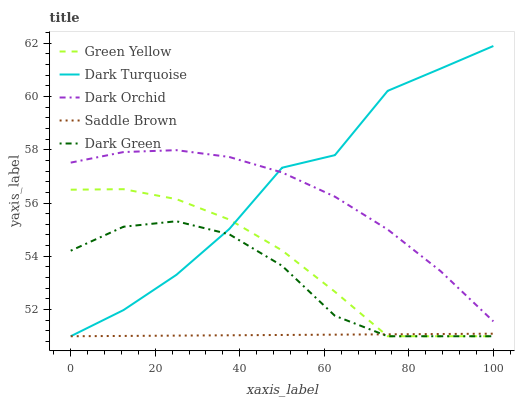Does Saddle Brown have the minimum area under the curve?
Answer yes or no. Yes. Does Dark Turquoise have the maximum area under the curve?
Answer yes or no. Yes. Does Green Yellow have the minimum area under the curve?
Answer yes or no. No. Does Green Yellow have the maximum area under the curve?
Answer yes or no. No. Is Saddle Brown the smoothest?
Answer yes or no. Yes. Is Dark Turquoise the roughest?
Answer yes or no. Yes. Is Green Yellow the smoothest?
Answer yes or no. No. Is Green Yellow the roughest?
Answer yes or no. No. Does Dark Turquoise have the lowest value?
Answer yes or no. Yes. Does Dark Orchid have the lowest value?
Answer yes or no. No. Does Dark Turquoise have the highest value?
Answer yes or no. Yes. Does Green Yellow have the highest value?
Answer yes or no. No. Is Saddle Brown less than Dark Orchid?
Answer yes or no. Yes. Is Dark Orchid greater than Green Yellow?
Answer yes or no. Yes. Does Dark Turquoise intersect Saddle Brown?
Answer yes or no. Yes. Is Dark Turquoise less than Saddle Brown?
Answer yes or no. No. Is Dark Turquoise greater than Saddle Brown?
Answer yes or no. No. Does Saddle Brown intersect Dark Orchid?
Answer yes or no. No. 